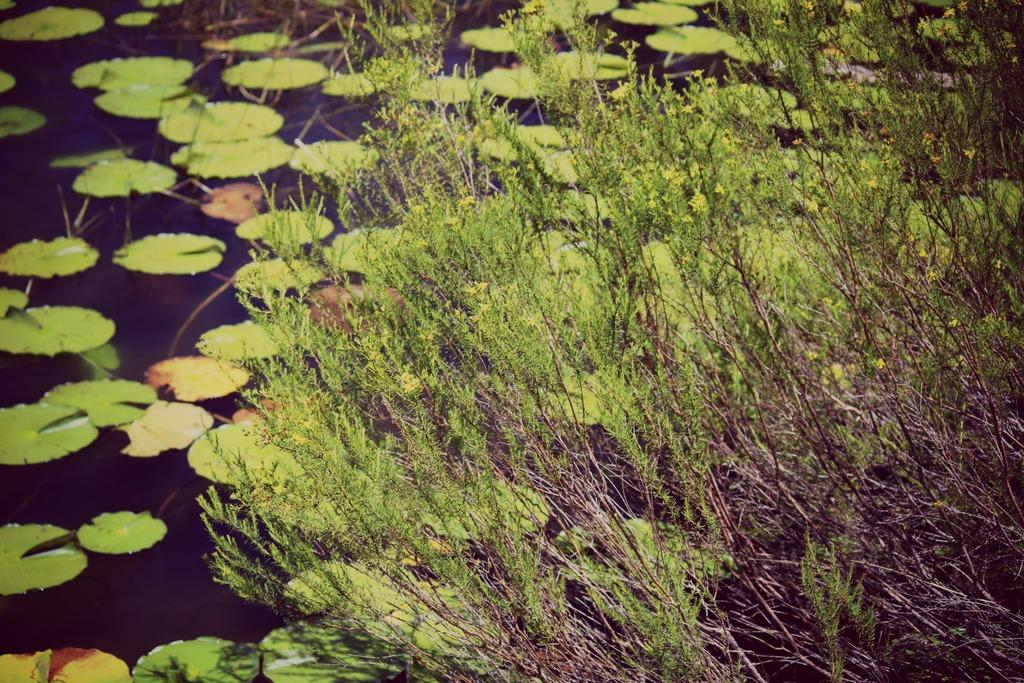What type of living organisms can be seen in the image? Plants can be seen in the image. What is the relationship between the plants and the water in the image? There are leaves on the water in the image. What type of fruit is being selected by the person wearing a mask in the image? There is no person wearing a mask or selecting any fruit in the image; it only features plants and leaves on the water. 